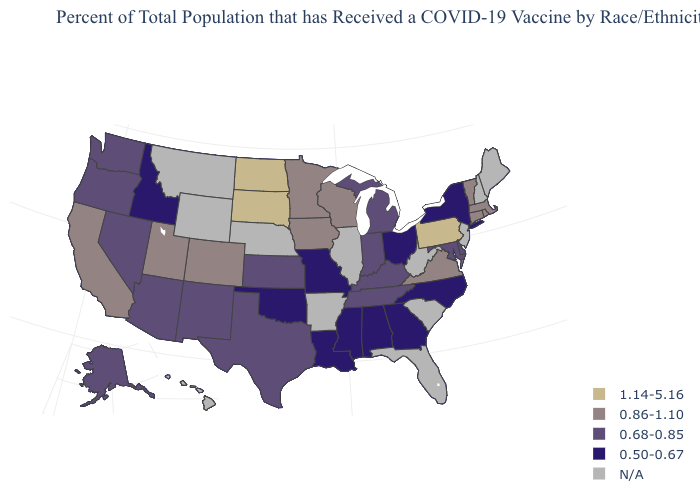What is the highest value in the MidWest ?
Keep it brief. 1.14-5.16. What is the value of Tennessee?
Keep it brief. 0.68-0.85. What is the value of Oregon?
Be succinct. 0.68-0.85. Name the states that have a value in the range 0.50-0.67?
Be succinct. Alabama, Georgia, Idaho, Louisiana, Mississippi, Missouri, New York, North Carolina, Ohio, Oklahoma. What is the lowest value in states that border Virginia?
Short answer required. 0.50-0.67. What is the value of Nevada?
Be succinct. 0.68-0.85. What is the value of South Dakota?
Write a very short answer. 1.14-5.16. Among the states that border Washington , does Idaho have the highest value?
Concise answer only. No. Among the states that border Alabama , does Mississippi have the highest value?
Answer briefly. No. Name the states that have a value in the range 0.68-0.85?
Be succinct. Alaska, Arizona, Delaware, Indiana, Kansas, Kentucky, Maryland, Michigan, Nevada, New Mexico, Oregon, Tennessee, Texas, Washington. What is the value of South Dakota?
Quick response, please. 1.14-5.16. Name the states that have a value in the range 0.50-0.67?
Keep it brief. Alabama, Georgia, Idaho, Louisiana, Mississippi, Missouri, New York, North Carolina, Ohio, Oklahoma. What is the highest value in the South ?
Give a very brief answer. 0.86-1.10. Which states have the highest value in the USA?
Short answer required. North Dakota, Pennsylvania, South Dakota. What is the highest value in states that border Nevada?
Give a very brief answer. 0.86-1.10. 